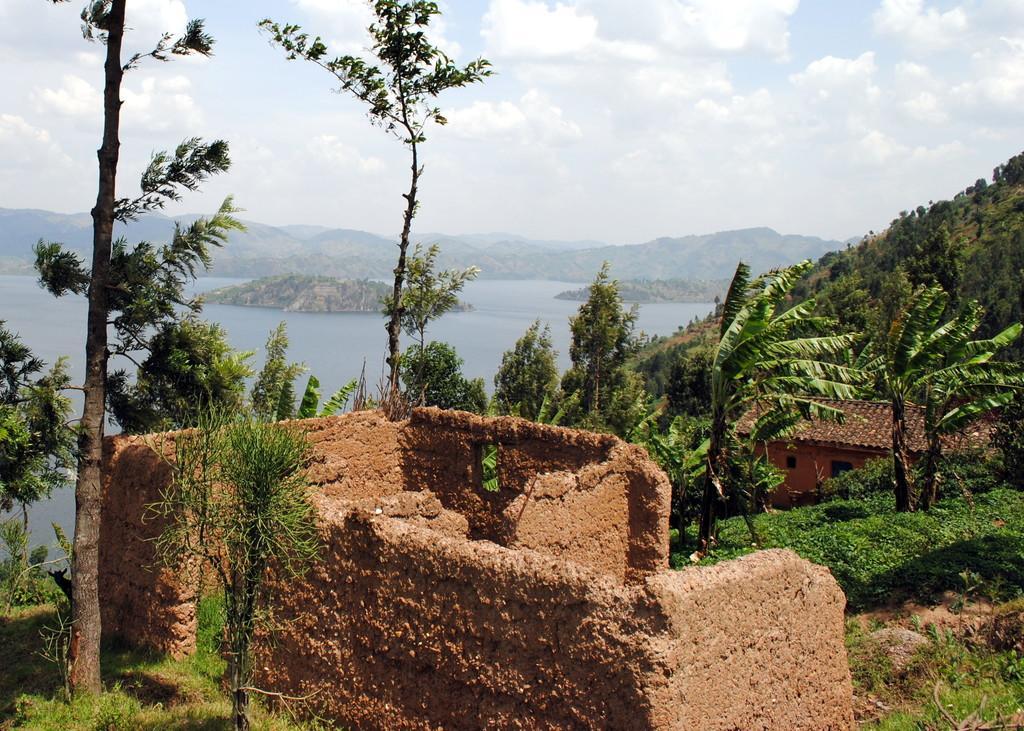Please provide a concise description of this image. In this image we can see the mountains, one river, one house, few walls in the middle of the image, one animal behind the tree on the left side of the image, some dried sticks on the bottom right side corner of the image, some trees, bushes, plants and grass on the ground. At the top there is the cloudy sky.   